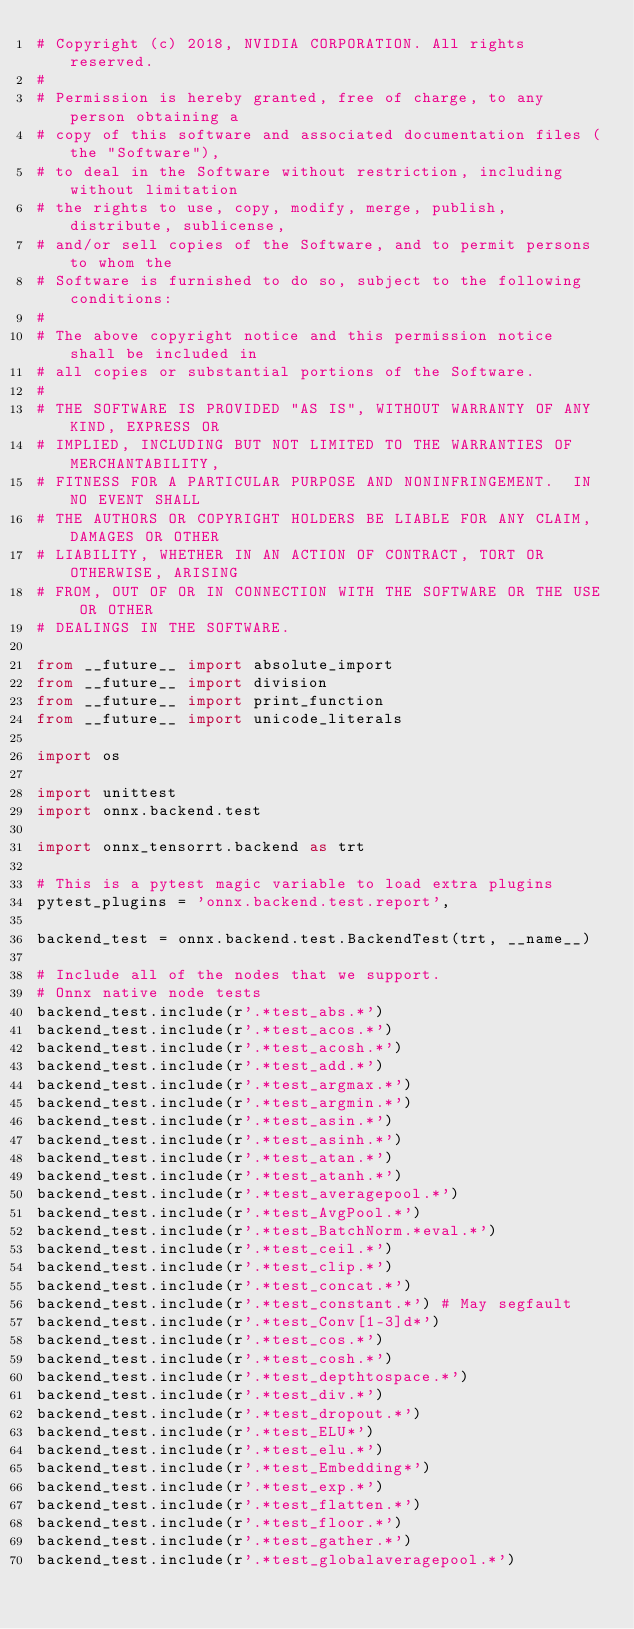Convert code to text. <code><loc_0><loc_0><loc_500><loc_500><_Python_># Copyright (c) 2018, NVIDIA CORPORATION. All rights reserved.
#
# Permission is hereby granted, free of charge, to any person obtaining a
# copy of this software and associated documentation files (the "Software"),
# to deal in the Software without restriction, including without limitation
# the rights to use, copy, modify, merge, publish, distribute, sublicense,
# and/or sell copies of the Software, and to permit persons to whom the
# Software is furnished to do so, subject to the following conditions:
#
# The above copyright notice and this permission notice shall be included in
# all copies or substantial portions of the Software.
#
# THE SOFTWARE IS PROVIDED "AS IS", WITHOUT WARRANTY OF ANY KIND, EXPRESS OR
# IMPLIED, INCLUDING BUT NOT LIMITED TO THE WARRANTIES OF MERCHANTABILITY,
# FITNESS FOR A PARTICULAR PURPOSE AND NONINFRINGEMENT.  IN NO EVENT SHALL
# THE AUTHORS OR COPYRIGHT HOLDERS BE LIABLE FOR ANY CLAIM, DAMAGES OR OTHER
# LIABILITY, WHETHER IN AN ACTION OF CONTRACT, TORT OR OTHERWISE, ARISING
# FROM, OUT OF OR IN CONNECTION WITH THE SOFTWARE OR THE USE OR OTHER
# DEALINGS IN THE SOFTWARE.

from __future__ import absolute_import
from __future__ import division
from __future__ import print_function
from __future__ import unicode_literals

import os

import unittest
import onnx.backend.test

import onnx_tensorrt.backend as trt

# This is a pytest magic variable to load extra plugins
pytest_plugins = 'onnx.backend.test.report',

backend_test = onnx.backend.test.BackendTest(trt, __name__)

# Include all of the nodes that we support. 
# Onnx native node tests
backend_test.include(r'.*test_abs.*')
backend_test.include(r'.*test_acos.*')
backend_test.include(r'.*test_acosh.*')
backend_test.include(r'.*test_add.*')
backend_test.include(r'.*test_argmax.*')
backend_test.include(r'.*test_argmin.*')
backend_test.include(r'.*test_asin.*')
backend_test.include(r'.*test_asinh.*')
backend_test.include(r'.*test_atan.*')
backend_test.include(r'.*test_atanh.*')
backend_test.include(r'.*test_averagepool.*')
backend_test.include(r'.*test_AvgPool.*')
backend_test.include(r'.*test_BatchNorm.*eval.*')
backend_test.include(r'.*test_ceil.*')
backend_test.include(r'.*test_clip.*')
backend_test.include(r'.*test_concat.*')
backend_test.include(r'.*test_constant.*') # May segfault
backend_test.include(r'.*test_Conv[1-3]d*')
backend_test.include(r'.*test_cos.*')
backend_test.include(r'.*test_cosh.*')
backend_test.include(r'.*test_depthtospace.*')
backend_test.include(r'.*test_div.*')
backend_test.include(r'.*test_dropout.*')
backend_test.include(r'.*test_ELU*')
backend_test.include(r'.*test_elu.*')
backend_test.include(r'.*test_Embedding*')
backend_test.include(r'.*test_exp.*')
backend_test.include(r'.*test_flatten.*')
backend_test.include(r'.*test_floor.*')
backend_test.include(r'.*test_gather.*')
backend_test.include(r'.*test_globalaveragepool.*')</code> 